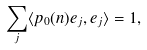Convert formula to latex. <formula><loc_0><loc_0><loc_500><loc_500>\sum _ { j } \langle p _ { 0 } ( n ) e _ { j } , e _ { j } \rangle = 1 ,</formula> 